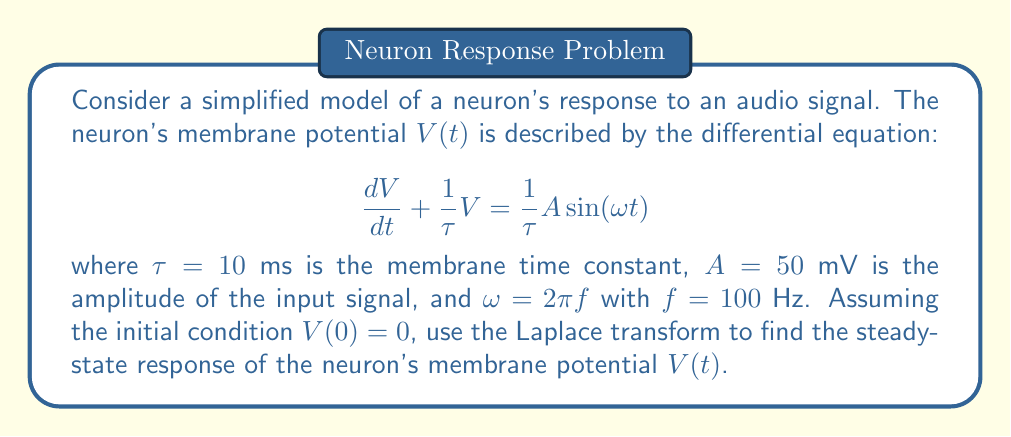Help me with this question. To solve this problem, we'll use the Laplace transform method:

1) First, let's take the Laplace transform of both sides of the equation:

   $$\mathcal{L}\left\{\frac{dV}{dt} + \frac{1}{\tau}V\right\} = \mathcal{L}\left\{\frac{1}{\tau}A\sin(\omega t)\right\}$$

2) Using Laplace transform properties:

   $$sV(s) - V(0) + \frac{1}{\tau}V(s) = \frac{1}{\tau}A\frac{\omega}{s^2 + \omega^2}$$

3) Substituting $V(0) = 0$ and rearranging:

   $$V(s)\left(s + \frac{1}{\tau}\right) = \frac{1}{\tau}A\frac{\omega}{s^2 + \omega^2}$$

4) Solving for $V(s)$:

   $$V(s) = \frac{A\omega}{\tau(s^2 + \omega^2)(s + \frac{1}{\tau})}$$

5) To find the partial fraction decomposition, let:

   $$V(s) = \frac{K_1s + K_2}{s^2 + \omega^2} + \frac{K_3}{s + \frac{1}{\tau}}$$

6) Solving for $K_1$, $K_2$, and $K_3$:

   $$K_1 = 0$$
   $$K_2 = \frac{A\omega}{\tau(\omega^2 + \frac{1}{\tau^2})}$$
   $$K_3 = -\frac{A\omega}{\tau(\omega^2 + \frac{1}{\tau^2})}$$

7) Taking the inverse Laplace transform:

   $$V(t) = K_2\sin(\omega t) + K_3e^{-t/\tau}$$

8) The steady-state response is obtained by letting $t \to \infty$, which eliminates the exponential term:

   $$V_{ss}(t) = \frac{A\omega}{\tau(\omega^2 + \frac{1}{\tau^2})}\sin(\omega t)$$

9) Substituting the given values:

   $$V_{ss}(t) = \frac{50 \cdot 2\pi \cdot 100}{0.01((2\pi \cdot 100)^2 + \frac{1}{0.01^2})}\sin(2\pi \cdot 100t)$$
Answer: The steady-state response of the neuron's membrane potential is:

$$V_{ss}(t) \approx 7.96 \sin(200\pi t) \text{ mV}$$ 